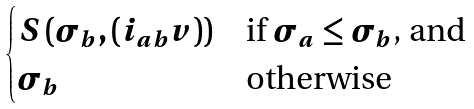<formula> <loc_0><loc_0><loc_500><loc_500>\begin{cases} S \left ( \sigma _ { b } , ( i _ { a b } v ) \right ) & \text {if $\sigma_{a} \leq \sigma_{b}$, and} \\ \sigma _ { b } & \text {otherwise} \end{cases}</formula> 